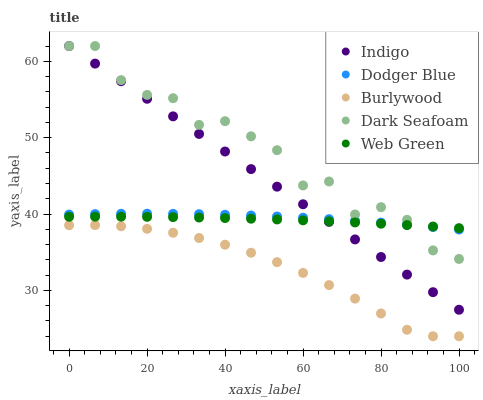Does Burlywood have the minimum area under the curve?
Answer yes or no. Yes. Does Dark Seafoam have the maximum area under the curve?
Answer yes or no. Yes. Does Dodger Blue have the minimum area under the curve?
Answer yes or no. No. Does Dodger Blue have the maximum area under the curve?
Answer yes or no. No. Is Indigo the smoothest?
Answer yes or no. Yes. Is Dark Seafoam the roughest?
Answer yes or no. Yes. Is Dodger Blue the smoothest?
Answer yes or no. No. Is Dodger Blue the roughest?
Answer yes or no. No. Does Burlywood have the lowest value?
Answer yes or no. Yes. Does Dodger Blue have the lowest value?
Answer yes or no. No. Does Indigo have the highest value?
Answer yes or no. Yes. Does Dodger Blue have the highest value?
Answer yes or no. No. Is Burlywood less than Dodger Blue?
Answer yes or no. Yes. Is Indigo greater than Burlywood?
Answer yes or no. Yes. Does Dark Seafoam intersect Web Green?
Answer yes or no. Yes. Is Dark Seafoam less than Web Green?
Answer yes or no. No. Is Dark Seafoam greater than Web Green?
Answer yes or no. No. Does Burlywood intersect Dodger Blue?
Answer yes or no. No. 